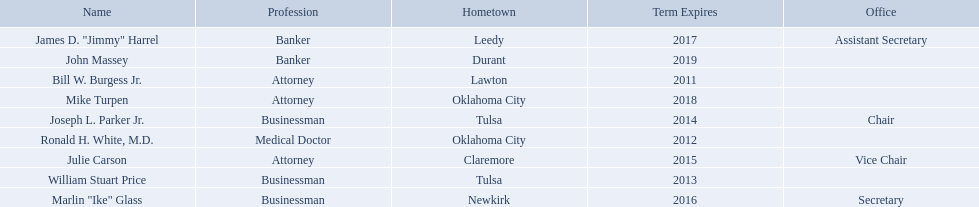Who are the regents? Bill W. Burgess Jr., Ronald H. White, M.D., William Stuart Price, Joseph L. Parker Jr., Julie Carson, Marlin "Ike" Glass, James D. "Jimmy" Harrel, Mike Turpen, John Massey. Of these who is a businessman? William Stuart Price, Joseph L. Parker Jr., Marlin "Ike" Glass. Of these whose hometown is tulsa? William Stuart Price, Joseph L. Parker Jr. Of these whose term expires in 2013? William Stuart Price. 